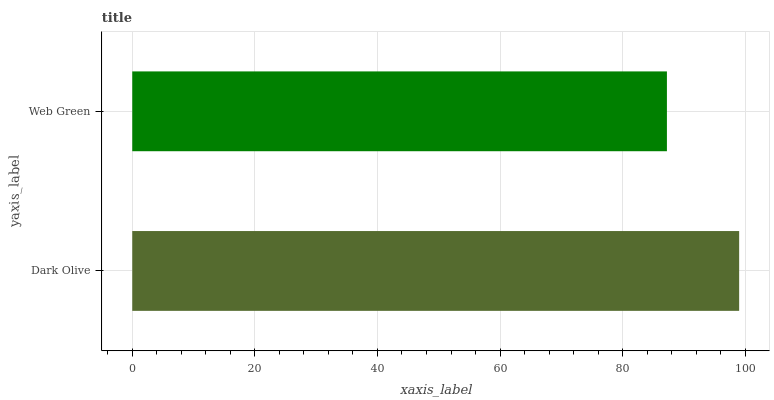Is Web Green the minimum?
Answer yes or no. Yes. Is Dark Olive the maximum?
Answer yes or no. Yes. Is Web Green the maximum?
Answer yes or no. No. Is Dark Olive greater than Web Green?
Answer yes or no. Yes. Is Web Green less than Dark Olive?
Answer yes or no. Yes. Is Web Green greater than Dark Olive?
Answer yes or no. No. Is Dark Olive less than Web Green?
Answer yes or no. No. Is Dark Olive the high median?
Answer yes or no. Yes. Is Web Green the low median?
Answer yes or no. Yes. Is Web Green the high median?
Answer yes or no. No. Is Dark Olive the low median?
Answer yes or no. No. 